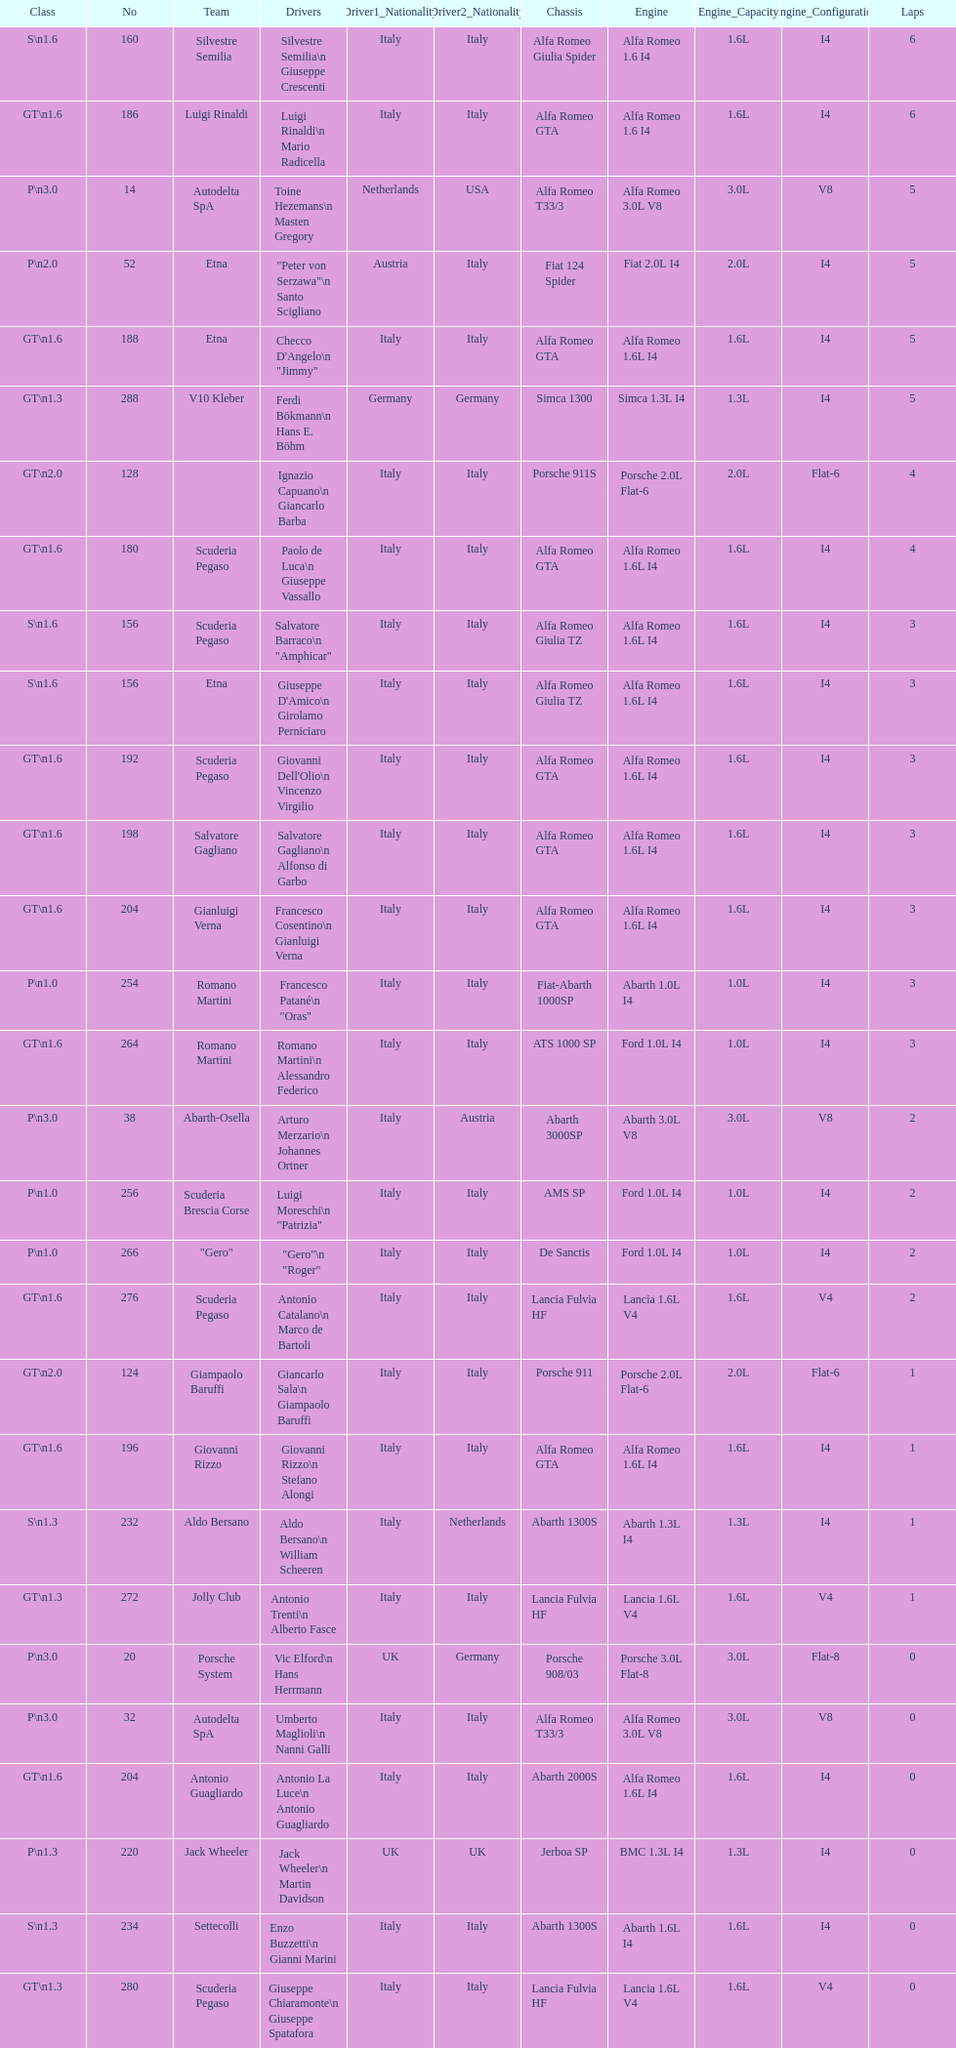How many teams failed to finish the race after 2 laps? 4. Give me the full table as a dictionary. {'header': ['Class', 'No', 'Team', 'Drivers', 'Driver1_Nationality', 'Driver2_Nationality', 'Chassis', 'Engine', 'Engine_Capacity', 'Engine_Configuration', 'Laps'], 'rows': [['S\\n1.6', '160', 'Silvestre Semilia', 'Silvestre Semilia\\n Giuseppe Crescenti', 'Italy', 'Italy', 'Alfa Romeo Giulia Spider', 'Alfa Romeo 1.6 I4', '1.6L', 'I4', '6'], ['GT\\n1.6', '186', 'Luigi Rinaldi', 'Luigi Rinaldi\\n Mario Radicella', 'Italy', 'Italy', 'Alfa Romeo GTA', 'Alfa Romeo 1.6 I4', '1.6L', 'I4', '6'], ['P\\n3.0', '14', 'Autodelta SpA', 'Toine Hezemans\\n Masten Gregory', 'Netherlands', 'USA', 'Alfa Romeo T33/3', 'Alfa Romeo 3.0L V8', '3.0L', 'V8', '5'], ['P\\n2.0', '52', 'Etna', '"Peter von Serzawa"\\n Santo Scigliano', 'Austria', 'Italy', 'Fiat 124 Spider', 'Fiat 2.0L I4', '2.0L', 'I4', '5'], ['GT\\n1.6', '188', 'Etna', 'Checco D\'Angelo\\n "Jimmy"', 'Italy', 'Italy', 'Alfa Romeo GTA', 'Alfa Romeo 1.6L I4', '1.6L', 'I4', '5'], ['GT\\n1.3', '288', 'V10 Kleber', 'Ferdi Bökmann\\n Hans E. Böhm', 'Germany', 'Germany', 'Simca 1300', 'Simca 1.3L I4', '1.3L', 'I4', '5'], ['GT\\n2.0', '128', '', 'Ignazio Capuano\\n Giancarlo Barba', 'Italy', 'Italy', 'Porsche 911S', 'Porsche 2.0L Flat-6', '2.0L', 'Flat-6', '4'], ['GT\\n1.6', '180', 'Scuderia Pegaso', 'Paolo de Luca\\n Giuseppe Vassallo', 'Italy', 'Italy', 'Alfa Romeo GTA', 'Alfa Romeo 1.6L I4', '1.6L', 'I4', '4'], ['S\\n1.6', '156', 'Scuderia Pegaso', 'Salvatore Barraco\\n "Amphicar"', 'Italy', 'Italy', 'Alfa Romeo Giulia TZ', 'Alfa Romeo 1.6L I4', '1.6L', 'I4', '3'], ['S\\n1.6', '156', 'Etna', "Giuseppe D'Amico\\n Girolamo Perniciaro", 'Italy', 'Italy', 'Alfa Romeo Giulia TZ', 'Alfa Romeo 1.6L I4', '1.6L', 'I4', '3'], ['GT\\n1.6', '192', 'Scuderia Pegaso', "Giovanni Dell'Olio\\n Vincenzo Virgilio", 'Italy', 'Italy', 'Alfa Romeo GTA', 'Alfa Romeo 1.6L I4', '1.6L', 'I4', '3'], ['GT\\n1.6', '198', 'Salvatore Gagliano', 'Salvatore Gagliano\\n Alfonso di Garbo', 'Italy', 'Italy', 'Alfa Romeo GTA', 'Alfa Romeo 1.6L I4', '1.6L', 'I4', '3'], ['GT\\n1.6', '204', 'Gianluigi Verna', 'Francesco Cosentino\\n Gianluigi Verna', 'Italy', 'Italy', 'Alfa Romeo GTA', 'Alfa Romeo 1.6L I4', '1.6L', 'I4', '3'], ['P\\n1.0', '254', 'Romano Martini', 'Francesco Patané\\n "Oras"', 'Italy', 'Italy', 'Fiat-Abarth 1000SP', 'Abarth 1.0L I4', '1.0L', 'I4', '3'], ['GT\\n1.6', '264', 'Romano Martini', 'Romano Martini\\n Alessandro Federico', 'Italy', 'Italy', 'ATS 1000 SP', 'Ford 1.0L I4', '1.0L', 'I4', '3'], ['P\\n3.0', '38', 'Abarth-Osella', 'Arturo Merzario\\n Johannes Ortner', 'Italy', 'Austria', 'Abarth 3000SP', 'Abarth 3.0L V8', '3.0L', 'V8', '2'], ['P\\n1.0', '256', 'Scuderia Brescia Corse', 'Luigi Moreschi\\n "Patrizia"', 'Italy', 'Italy', 'AMS SP', 'Ford 1.0L I4', '1.0L', 'I4', '2'], ['P\\n1.0', '266', '"Gero"', '"Gero"\\n "Roger"', 'Italy', 'Italy', 'De Sanctis', 'Ford 1.0L I4', '1.0L', 'I4', '2'], ['GT\\n1.6', '276', 'Scuderia Pegaso', 'Antonio Catalano\\n Marco de Bartoli', 'Italy', 'Italy', 'Lancia Fulvia HF', 'Lancia 1.6L V4', '1.6L', 'V4', '2'], ['GT\\n2.0', '124', 'Giampaolo Baruffi', 'Giancarlo Sala\\n Giampaolo Baruffi', 'Italy', 'Italy', 'Porsche 911', 'Porsche 2.0L Flat-6', '2.0L', 'Flat-6', '1'], ['GT\\n1.6', '196', 'Giovanni Rizzo', 'Giovanni Rizzo\\n Stefano Alongi', 'Italy', 'Italy', 'Alfa Romeo GTA', 'Alfa Romeo 1.6L I4', '1.6L', 'I4', '1'], ['S\\n1.3', '232', 'Aldo Bersano', 'Aldo Bersano\\n William Scheeren', 'Italy', 'Netherlands', 'Abarth 1300S', 'Abarth 1.3L I4', '1.3L', 'I4', '1'], ['GT\\n1.3', '272', 'Jolly Club', 'Antonio Trenti\\n Alberto Fasce', 'Italy', 'Italy', 'Lancia Fulvia HF', 'Lancia 1.6L V4', '1.6L', 'V4', '1'], ['P\\n3.0', '20', 'Porsche System', 'Vic Elford\\n Hans Herrmann', 'UK', 'Germany', 'Porsche 908/03', 'Porsche 3.0L Flat-8', '3.0L', 'Flat-8', '0'], ['P\\n3.0', '32', 'Autodelta SpA', 'Umberto Maglioli\\n Nanni Galli', 'Italy', 'Italy', 'Alfa Romeo T33/3', 'Alfa Romeo 3.0L V8', '3.0L', 'V8', '0'], ['GT\\n1.6', '204', 'Antonio Guagliardo', 'Antonio La Luce\\n Antonio Guagliardo', 'Italy', 'Italy', 'Abarth 2000S', 'Alfa Romeo 1.6L I4', '1.6L', 'I4', '0'], ['P\\n1.3', '220', 'Jack Wheeler', 'Jack Wheeler\\n Martin Davidson', 'UK', 'UK', 'Jerboa SP', 'BMC 1.3L I4', '1.3L', 'I4', '0'], ['S\\n1.3', '234', 'Settecolli', 'Enzo Buzzetti\\n Gianni Marini', 'Italy', 'Italy', 'Abarth 1300S', 'Abarth 1.6L I4', '1.6L', 'I4', '0'], ['GT\\n1.3', '280', 'Scuderia Pegaso', 'Giuseppe Chiaramonte\\n Giuseppe Spatafora', 'Italy', 'Italy', 'Lancia Fulvia HF', 'Lancia 1.6L V4', '1.6L', 'V4', '0']]} 